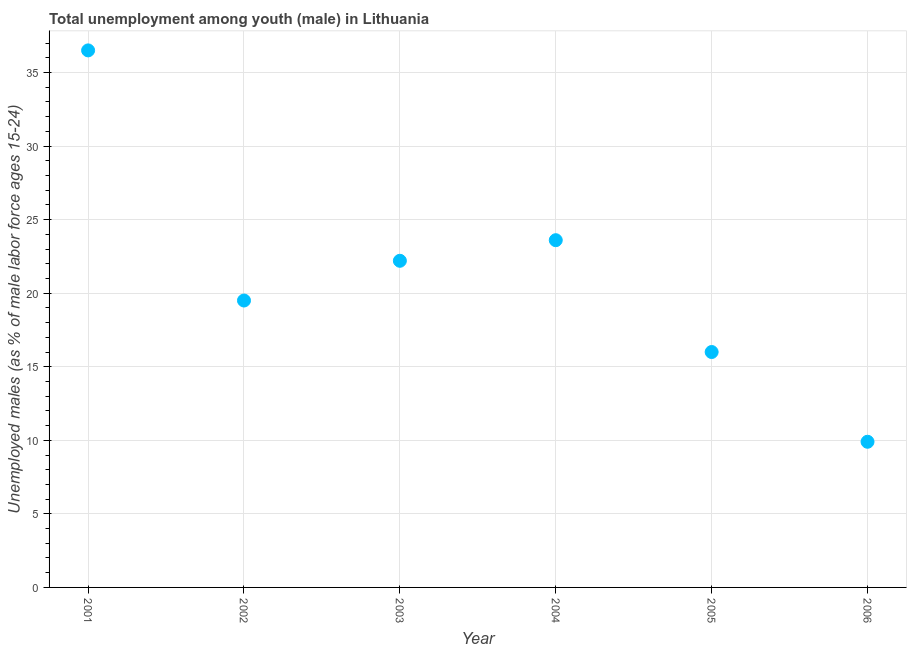Across all years, what is the maximum unemployed male youth population?
Give a very brief answer. 36.5. Across all years, what is the minimum unemployed male youth population?
Provide a short and direct response. 9.9. In which year was the unemployed male youth population minimum?
Your response must be concise. 2006. What is the sum of the unemployed male youth population?
Ensure brevity in your answer.  127.7. What is the difference between the unemployed male youth population in 2001 and 2003?
Give a very brief answer. 14.3. What is the average unemployed male youth population per year?
Offer a very short reply. 21.28. What is the median unemployed male youth population?
Keep it short and to the point. 20.85. Do a majority of the years between 2001 and 2006 (inclusive) have unemployed male youth population greater than 5 %?
Ensure brevity in your answer.  Yes. What is the ratio of the unemployed male youth population in 2001 to that in 2006?
Your response must be concise. 3.69. Is the unemployed male youth population in 2002 less than that in 2005?
Provide a short and direct response. No. What is the difference between the highest and the second highest unemployed male youth population?
Ensure brevity in your answer.  12.9. Is the sum of the unemployed male youth population in 2002 and 2005 greater than the maximum unemployed male youth population across all years?
Offer a terse response. No. What is the difference between the highest and the lowest unemployed male youth population?
Offer a very short reply. 26.6. In how many years, is the unemployed male youth population greater than the average unemployed male youth population taken over all years?
Ensure brevity in your answer.  3. Are the values on the major ticks of Y-axis written in scientific E-notation?
Make the answer very short. No. What is the title of the graph?
Provide a short and direct response. Total unemployment among youth (male) in Lithuania. What is the label or title of the Y-axis?
Give a very brief answer. Unemployed males (as % of male labor force ages 15-24). What is the Unemployed males (as % of male labor force ages 15-24) in 2001?
Ensure brevity in your answer.  36.5. What is the Unemployed males (as % of male labor force ages 15-24) in 2002?
Provide a short and direct response. 19.5. What is the Unemployed males (as % of male labor force ages 15-24) in 2003?
Give a very brief answer. 22.2. What is the Unemployed males (as % of male labor force ages 15-24) in 2004?
Your response must be concise. 23.6. What is the Unemployed males (as % of male labor force ages 15-24) in 2006?
Offer a terse response. 9.9. What is the difference between the Unemployed males (as % of male labor force ages 15-24) in 2001 and 2002?
Provide a short and direct response. 17. What is the difference between the Unemployed males (as % of male labor force ages 15-24) in 2001 and 2005?
Offer a terse response. 20.5. What is the difference between the Unemployed males (as % of male labor force ages 15-24) in 2001 and 2006?
Ensure brevity in your answer.  26.6. What is the difference between the Unemployed males (as % of male labor force ages 15-24) in 2002 and 2003?
Your answer should be very brief. -2.7. What is the difference between the Unemployed males (as % of male labor force ages 15-24) in 2002 and 2004?
Provide a short and direct response. -4.1. What is the difference between the Unemployed males (as % of male labor force ages 15-24) in 2002 and 2005?
Provide a succinct answer. 3.5. What is the difference between the Unemployed males (as % of male labor force ages 15-24) in 2003 and 2006?
Keep it short and to the point. 12.3. What is the difference between the Unemployed males (as % of male labor force ages 15-24) in 2005 and 2006?
Ensure brevity in your answer.  6.1. What is the ratio of the Unemployed males (as % of male labor force ages 15-24) in 2001 to that in 2002?
Provide a short and direct response. 1.87. What is the ratio of the Unemployed males (as % of male labor force ages 15-24) in 2001 to that in 2003?
Offer a terse response. 1.64. What is the ratio of the Unemployed males (as % of male labor force ages 15-24) in 2001 to that in 2004?
Provide a succinct answer. 1.55. What is the ratio of the Unemployed males (as % of male labor force ages 15-24) in 2001 to that in 2005?
Offer a very short reply. 2.28. What is the ratio of the Unemployed males (as % of male labor force ages 15-24) in 2001 to that in 2006?
Provide a succinct answer. 3.69. What is the ratio of the Unemployed males (as % of male labor force ages 15-24) in 2002 to that in 2003?
Make the answer very short. 0.88. What is the ratio of the Unemployed males (as % of male labor force ages 15-24) in 2002 to that in 2004?
Keep it short and to the point. 0.83. What is the ratio of the Unemployed males (as % of male labor force ages 15-24) in 2002 to that in 2005?
Your response must be concise. 1.22. What is the ratio of the Unemployed males (as % of male labor force ages 15-24) in 2002 to that in 2006?
Provide a succinct answer. 1.97. What is the ratio of the Unemployed males (as % of male labor force ages 15-24) in 2003 to that in 2004?
Your answer should be very brief. 0.94. What is the ratio of the Unemployed males (as % of male labor force ages 15-24) in 2003 to that in 2005?
Give a very brief answer. 1.39. What is the ratio of the Unemployed males (as % of male labor force ages 15-24) in 2003 to that in 2006?
Offer a very short reply. 2.24. What is the ratio of the Unemployed males (as % of male labor force ages 15-24) in 2004 to that in 2005?
Your response must be concise. 1.48. What is the ratio of the Unemployed males (as % of male labor force ages 15-24) in 2004 to that in 2006?
Provide a short and direct response. 2.38. What is the ratio of the Unemployed males (as % of male labor force ages 15-24) in 2005 to that in 2006?
Keep it short and to the point. 1.62. 